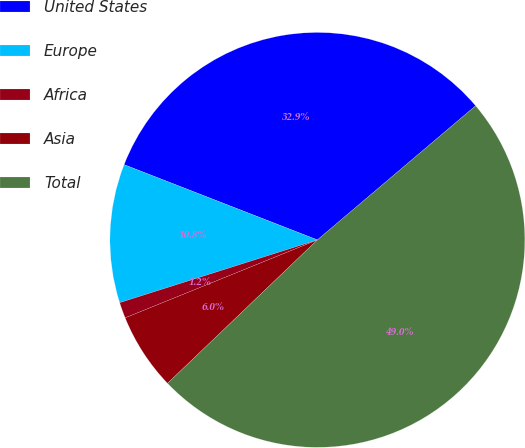<chart> <loc_0><loc_0><loc_500><loc_500><pie_chart><fcel>United States<fcel>Europe<fcel>Africa<fcel>Asia<fcel>Total<nl><fcel>32.9%<fcel>10.8%<fcel>1.24%<fcel>6.02%<fcel>49.04%<nl></chart> 